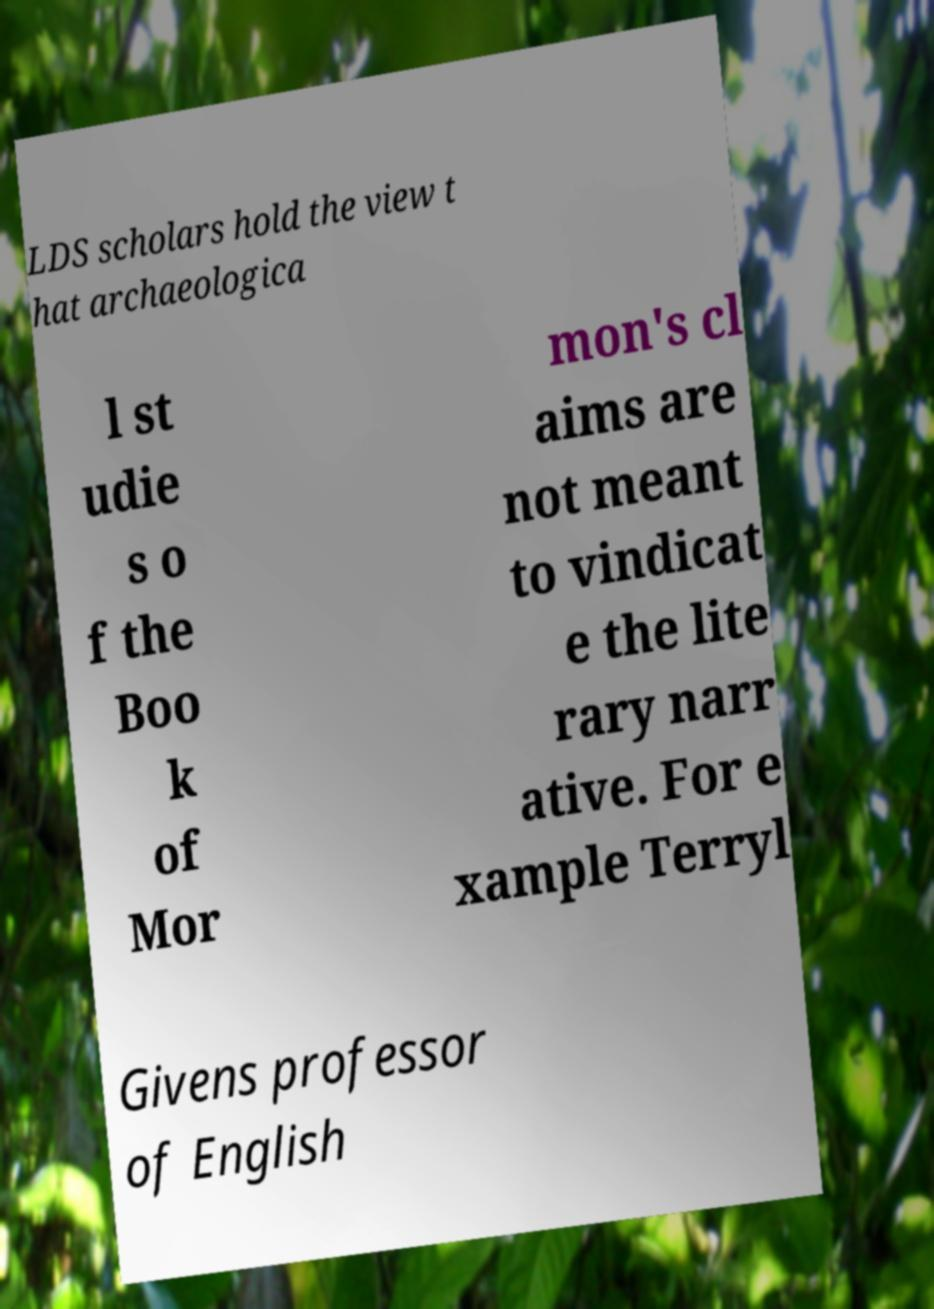Please read and relay the text visible in this image. What does it say? LDS scholars hold the view t hat archaeologica l st udie s o f the Boo k of Mor mon's cl aims are not meant to vindicat e the lite rary narr ative. For e xample Terryl Givens professor of English 